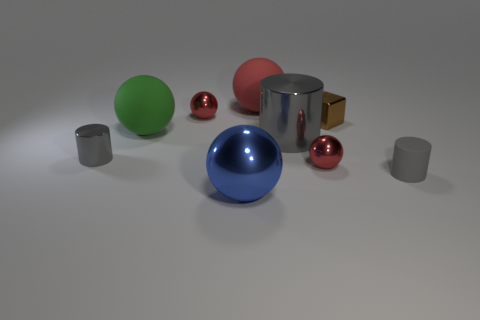Subtract all big metal cylinders. How many cylinders are left? 2 Subtract all blue balls. How many balls are left? 4 Subtract 0 green cylinders. How many objects are left? 9 Subtract all cylinders. How many objects are left? 6 Subtract 5 balls. How many balls are left? 0 Subtract all purple spheres. Subtract all yellow blocks. How many spheres are left? 5 Subtract all brown spheres. How many blue blocks are left? 0 Subtract all rubber cylinders. Subtract all small cubes. How many objects are left? 7 Add 7 big matte objects. How many big matte objects are left? 9 Add 5 small cyan balls. How many small cyan balls exist? 5 